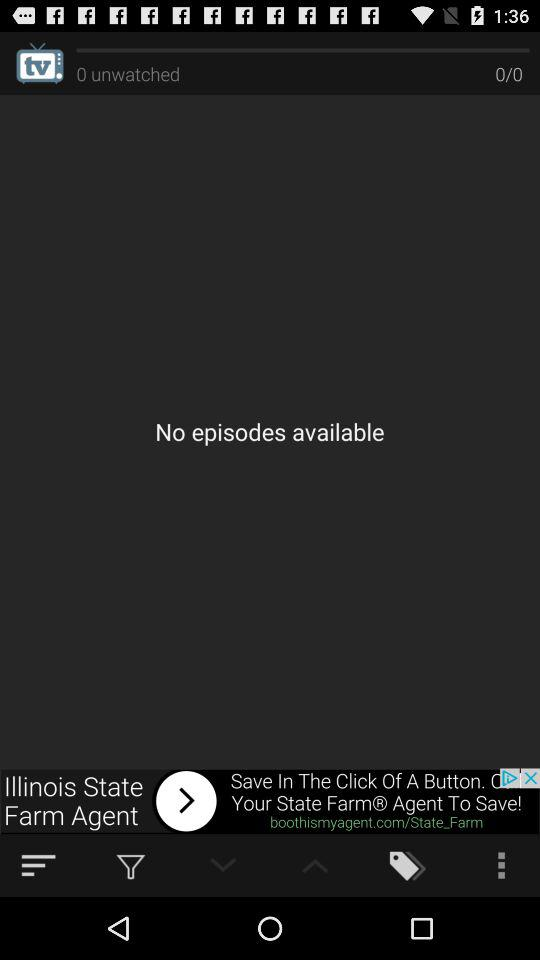How many episodes are available?
Answer the question using a single word or phrase. 0 